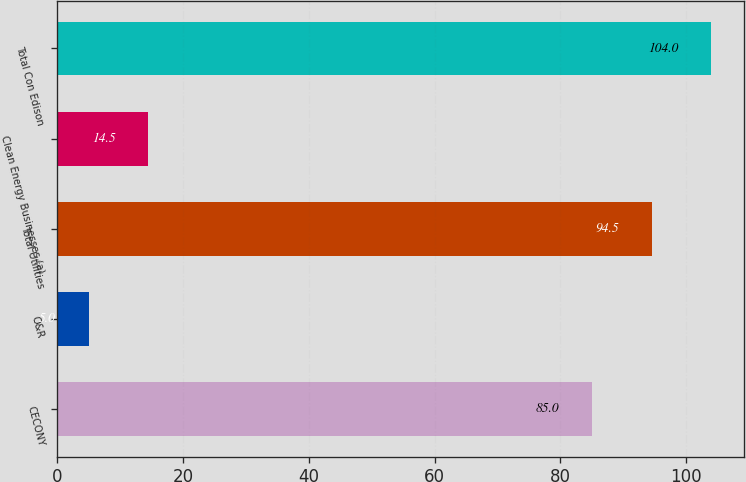Convert chart to OTSL. <chart><loc_0><loc_0><loc_500><loc_500><bar_chart><fcel>CECONY<fcel>O&R<fcel>Total Utilities<fcel>Clean Energy Businesses (a)<fcel>Total Con Edison<nl><fcel>85<fcel>5<fcel>94.5<fcel>14.5<fcel>104<nl></chart> 